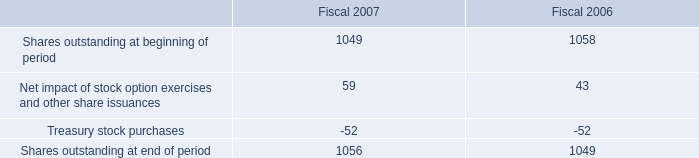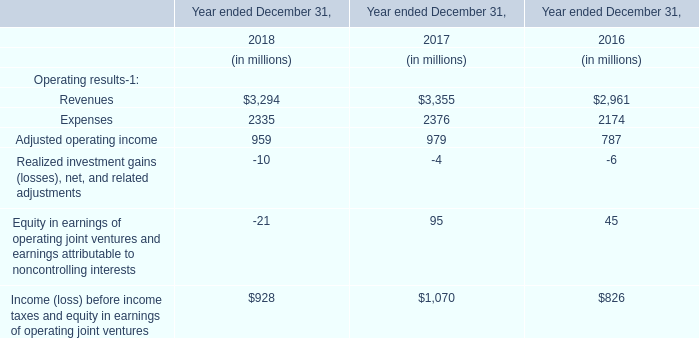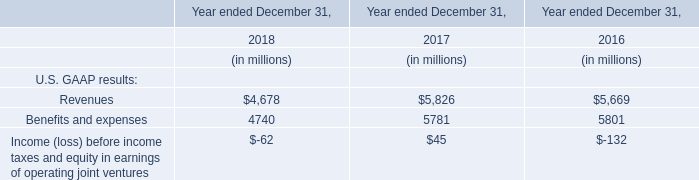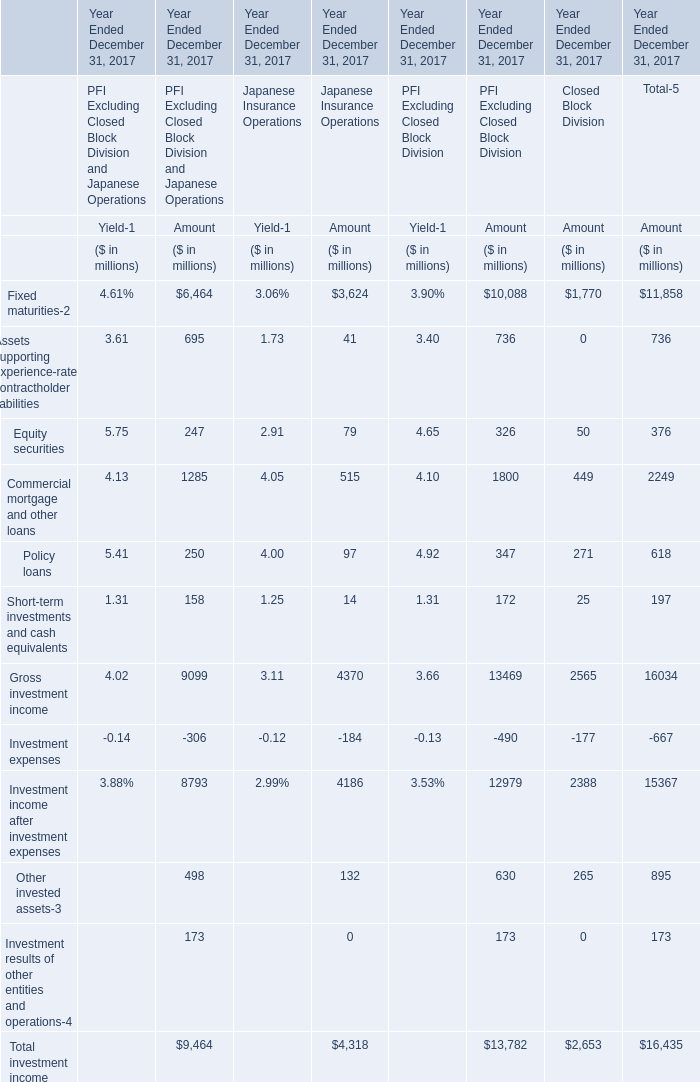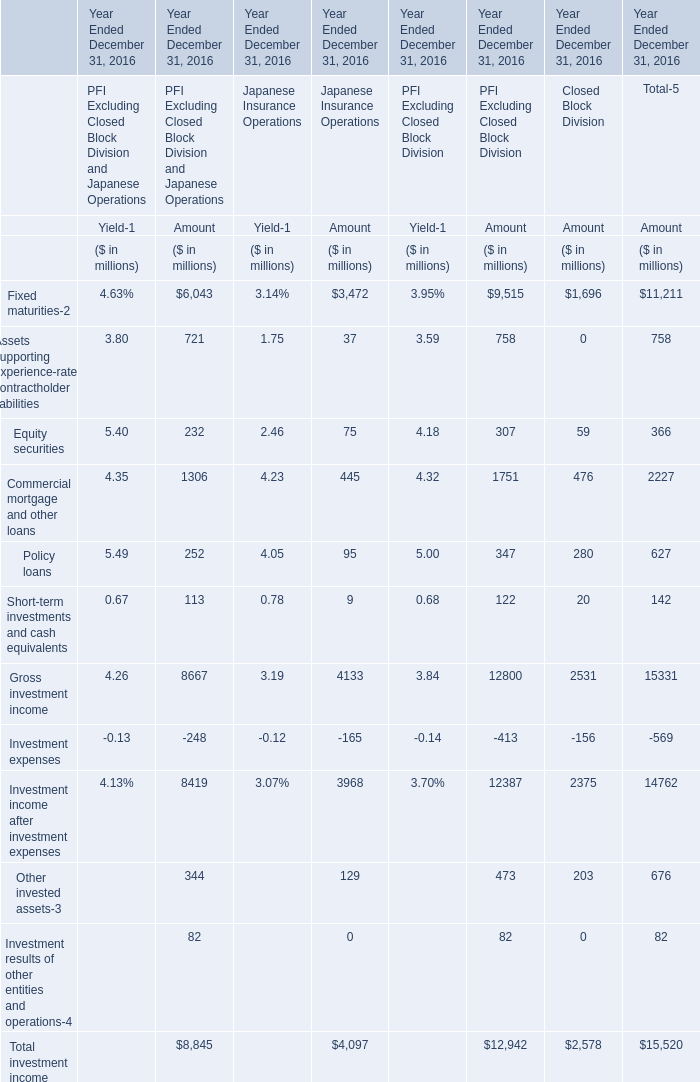What was the total amount of the Policy loans for Amount in the sections where Equity securities for Amount greater than 200? (in million) 
Computations: (252 + 347)
Answer: 599.0. 